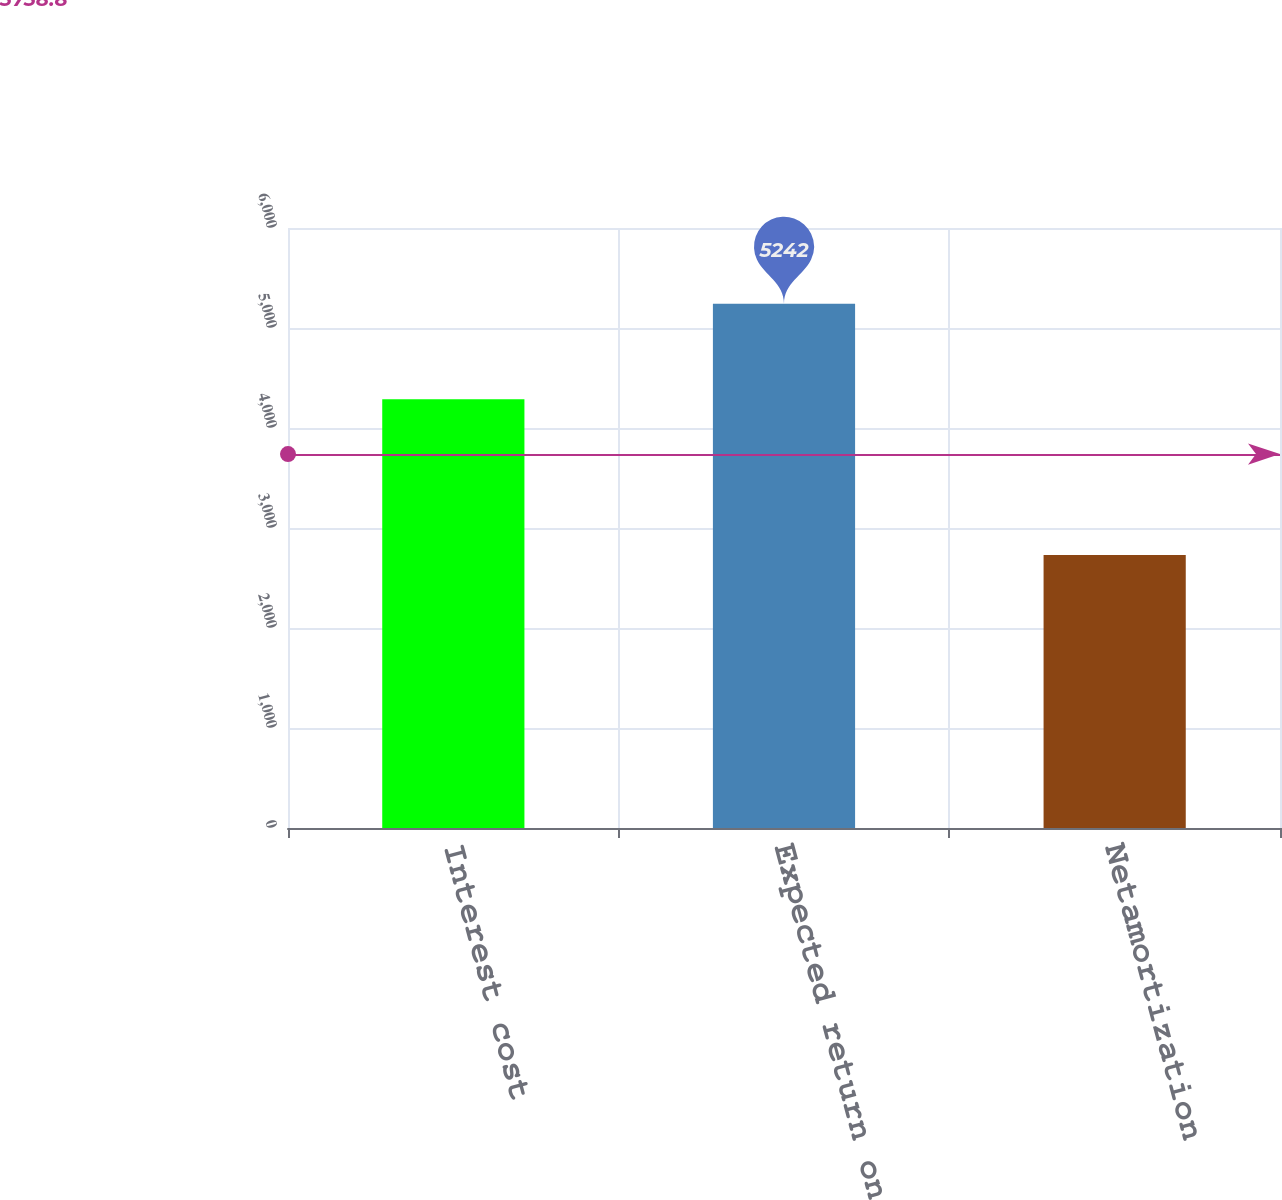Convert chart. <chart><loc_0><loc_0><loc_500><loc_500><bar_chart><fcel>Interest cost<fcel>Expected return on plan assets<fcel>Netamortization<nl><fcel>4288<fcel>5242<fcel>2730<nl></chart> 